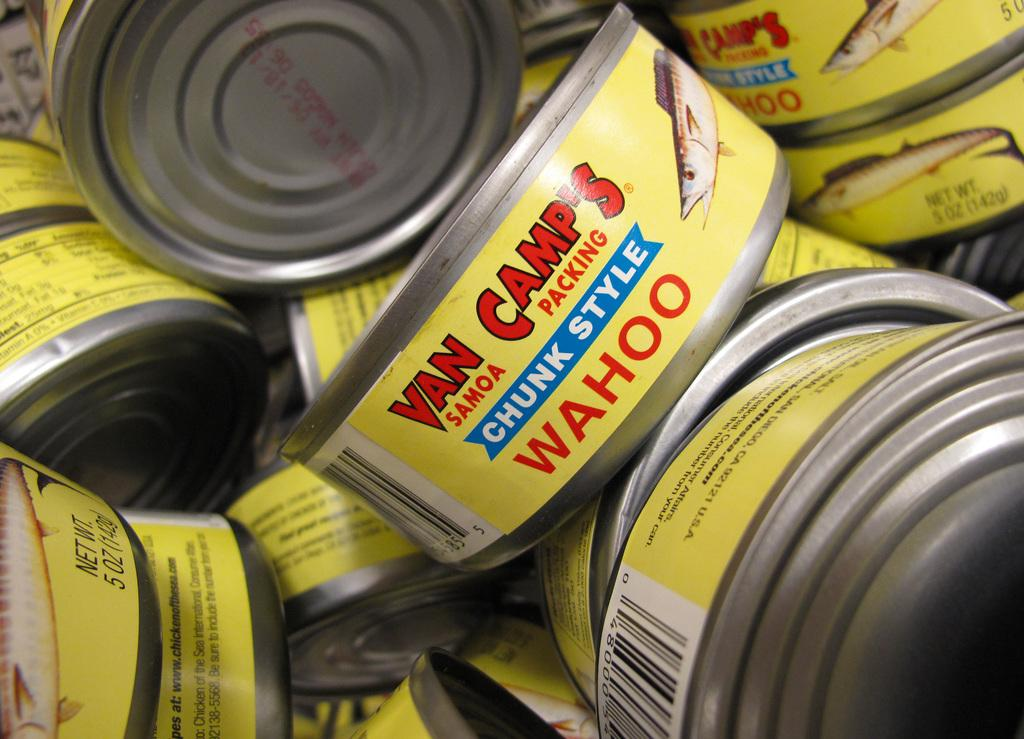<image>
Write a terse but informative summary of the picture. Many cans of chunk style Wahoo from Van Camp's. 